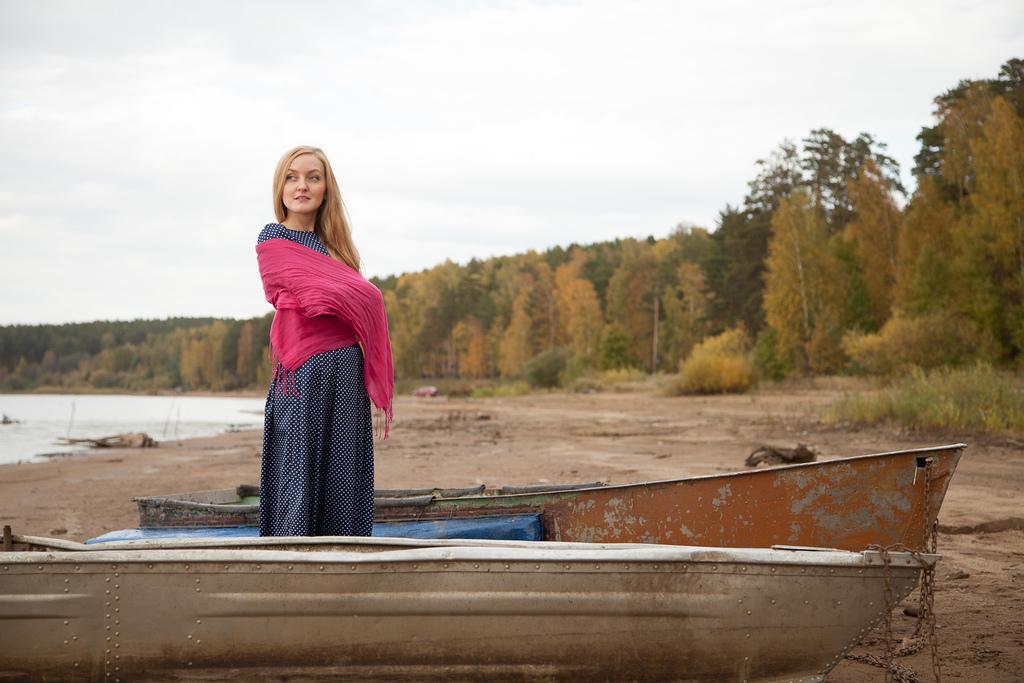How would you summarize this image in a sentence or two? In this image I can see a person standing and the person is wearing pink and blue color dress. In front I can see a boat, background I can see trees in green color and the sky is in white color. 